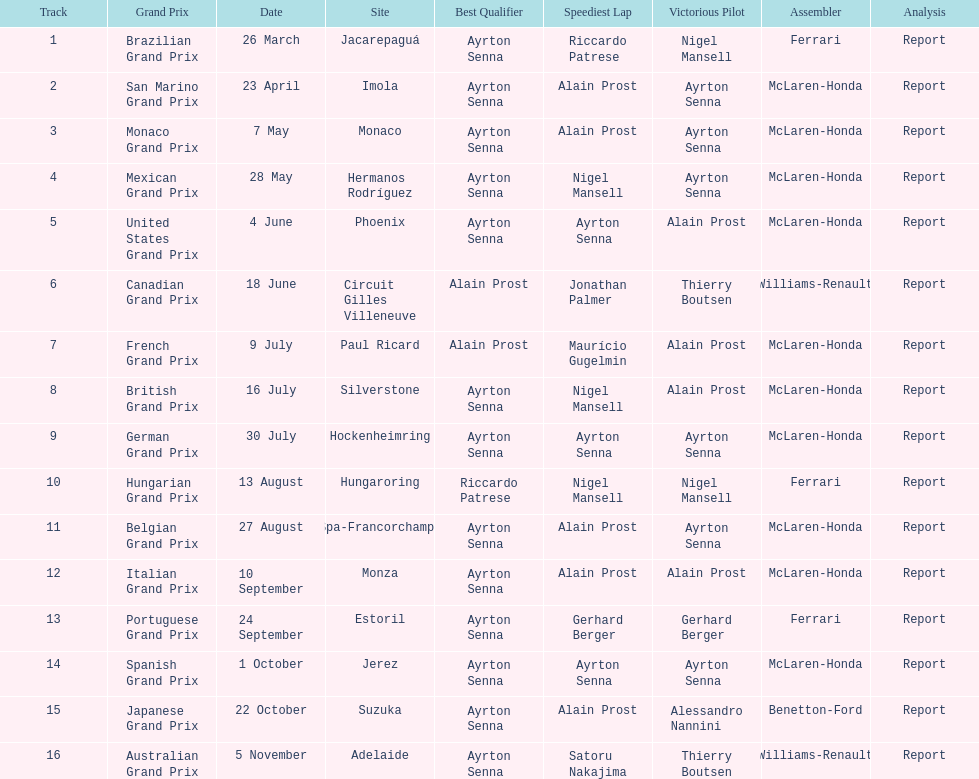What grand prix was before the san marino grand prix? Brazilian Grand Prix. 